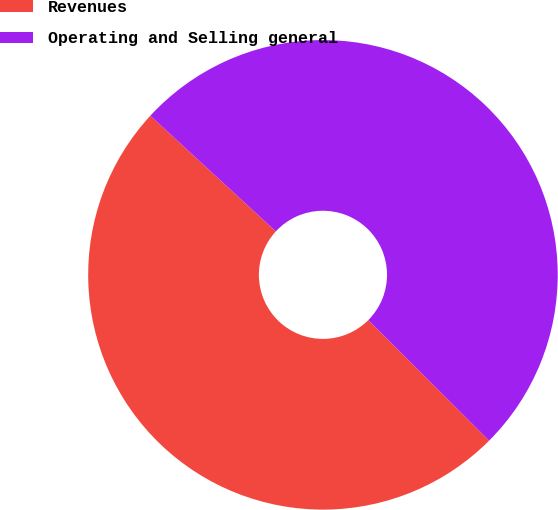Convert chart to OTSL. <chart><loc_0><loc_0><loc_500><loc_500><pie_chart><fcel>Revenues<fcel>Operating and Selling general<nl><fcel>49.37%<fcel>50.63%<nl></chart> 